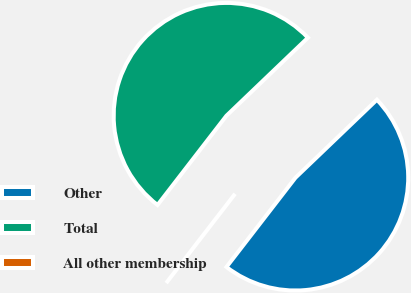<chart> <loc_0><loc_0><loc_500><loc_500><pie_chart><fcel>Other<fcel>Total<fcel>All other membership<nl><fcel>47.62%<fcel>52.38%<fcel>0.0%<nl></chart> 